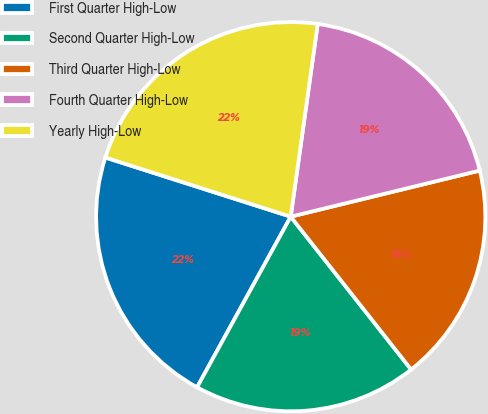Convert chart to OTSL. <chart><loc_0><loc_0><loc_500><loc_500><pie_chart><fcel>First Quarter High-Low<fcel>Second Quarter High-Low<fcel>Third Quarter High-Low<fcel>Fourth Quarter High-Low<fcel>Yearly High-Low<nl><fcel>21.93%<fcel>18.61%<fcel>18.19%<fcel>18.98%<fcel>22.3%<nl></chart> 